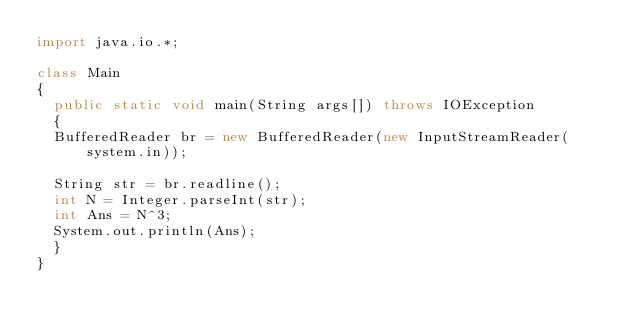Convert code to text. <code><loc_0><loc_0><loc_500><loc_500><_Java_>import java.io.*;

class Main
{
	public static void main(String args[]) throws IOException
	{
	BufferedReader br = new BufferedReader(new InputStreamReader(system.in));

	String str = br.readline();
	int N = Integer.parseInt(str);
	int Ans = N^3;
	System.out.println(Ans);
	}
}</code> 